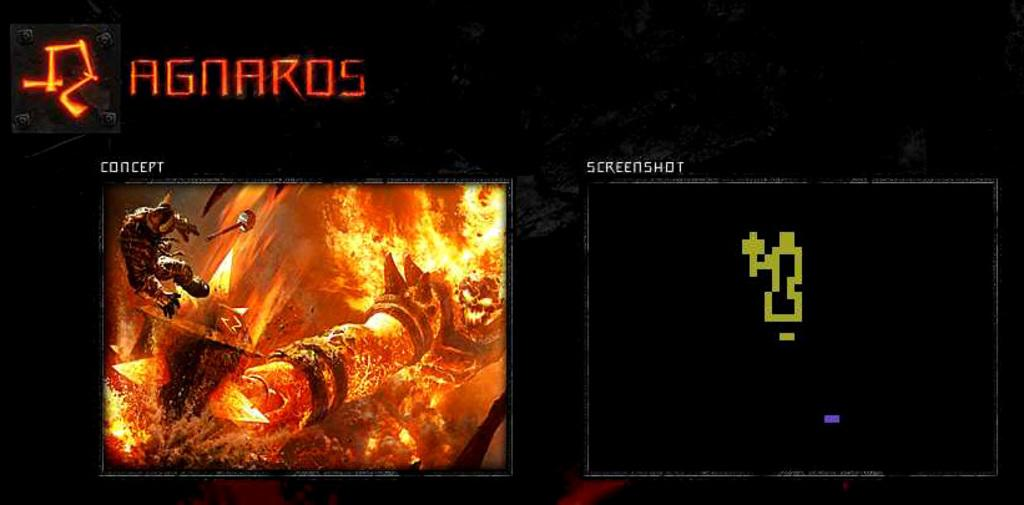<image>
Summarize the visual content of the image. The concept is much more detailed than the screenshot. 